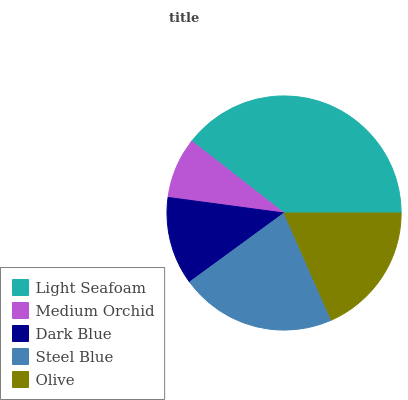Is Medium Orchid the minimum?
Answer yes or no. Yes. Is Light Seafoam the maximum?
Answer yes or no. Yes. Is Dark Blue the minimum?
Answer yes or no. No. Is Dark Blue the maximum?
Answer yes or no. No. Is Dark Blue greater than Medium Orchid?
Answer yes or no. Yes. Is Medium Orchid less than Dark Blue?
Answer yes or no. Yes. Is Medium Orchid greater than Dark Blue?
Answer yes or no. No. Is Dark Blue less than Medium Orchid?
Answer yes or no. No. Is Olive the high median?
Answer yes or no. Yes. Is Olive the low median?
Answer yes or no. Yes. Is Steel Blue the high median?
Answer yes or no. No. Is Dark Blue the low median?
Answer yes or no. No. 